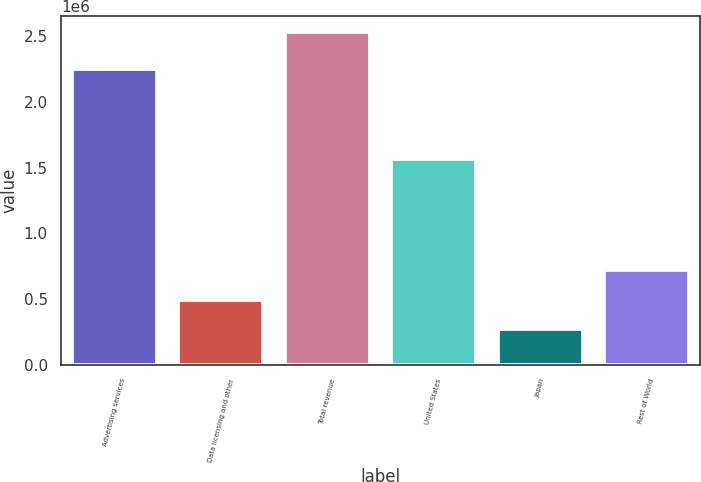<chart> <loc_0><loc_0><loc_500><loc_500><bar_chart><fcel>Advertising services<fcel>Data licensing and other<fcel>Total revenue<fcel>United States<fcel>Japan<fcel>Rest of World<nl><fcel>2.24805e+06<fcel>494608<fcel>2.52962e+06<fcel>1.56478e+06<fcel>268496<fcel>720721<nl></chart> 